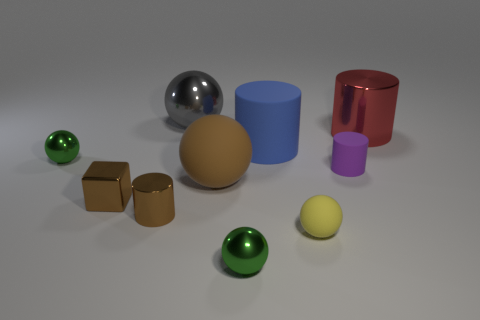Subtract all small yellow matte balls. How many balls are left? 4 Subtract all blue cylinders. How many cylinders are left? 3 Subtract all blocks. How many objects are left? 9 Subtract all blue spheres. How many purple cylinders are left? 1 Subtract all small purple cylinders. Subtract all small green things. How many objects are left? 7 Add 6 brown cylinders. How many brown cylinders are left? 7 Add 10 green rubber objects. How many green rubber objects exist? 10 Subtract 0 blue balls. How many objects are left? 10 Subtract 1 blocks. How many blocks are left? 0 Subtract all purple cylinders. Subtract all brown cubes. How many cylinders are left? 3 